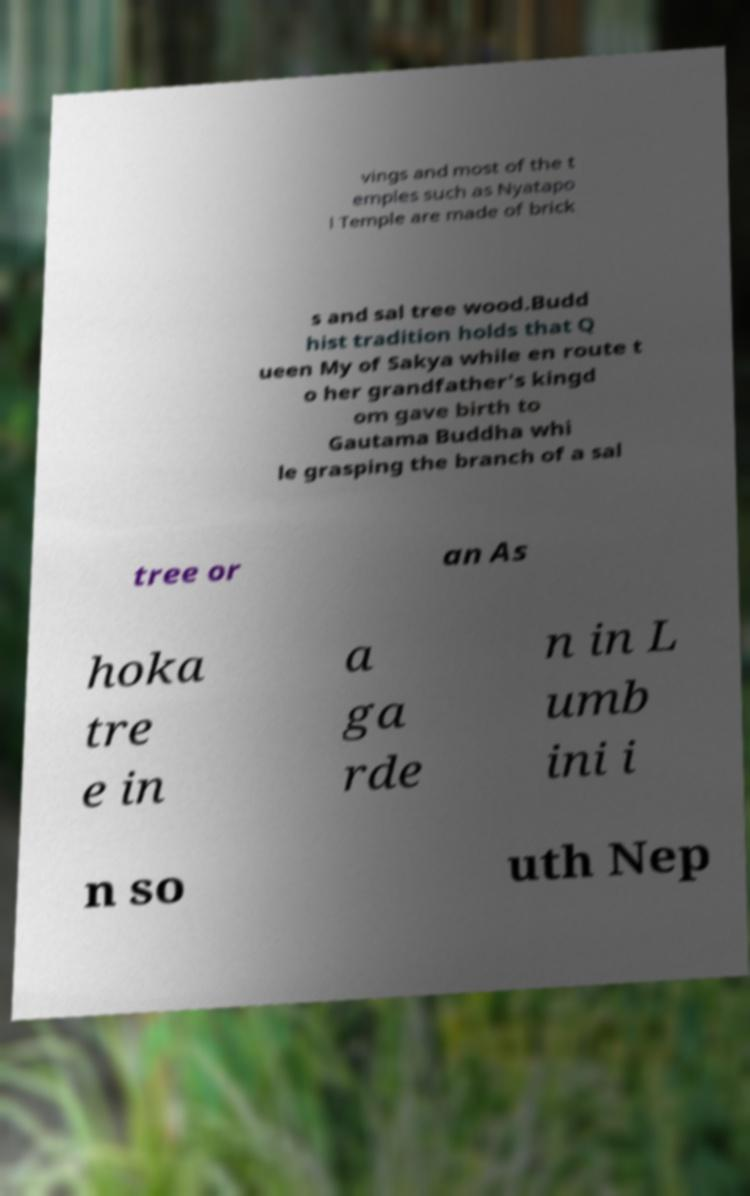What messages or text are displayed in this image? I need them in a readable, typed format. vings and most of the t emples such as Nyatapo l Temple are made of brick s and sal tree wood.Budd hist tradition holds that Q ueen My of Sakya while en route t o her grandfather's kingd om gave birth to Gautama Buddha whi le grasping the branch of a sal tree or an As hoka tre e in a ga rde n in L umb ini i n so uth Nep 